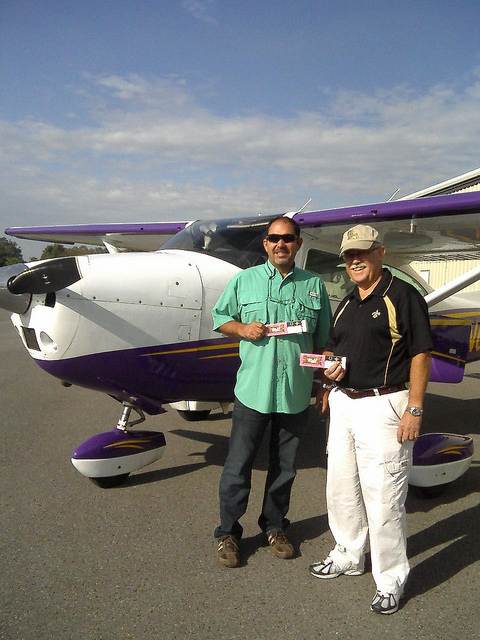Can you tell me what model the airplane might be? While I'm not able to search for specific airplane models or registry information, the aircraft in the image appears to be a small, single-engine propeller plane, characterized by its high-wing design and tricycle undercarriage. This design is typical of general aviation aircraft used for private and recreational flying. 